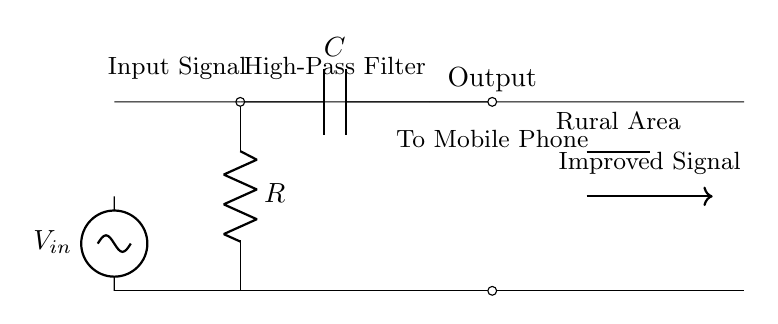What is the input voltage indicated in the diagram? The input voltage is labeled as V_in, which is represented as a voltage source on the diagram.
Answer: V_in What type of filter is represented in this circuit? The circuit diagram clearly states "High-Pass Filter" at the top, indicating the type of filter.
Answer: High-Pass Filter What component is connected to the output of this circuit? The output is connected to the mobile phone component, which is indicated by "To Mobile Phone" under the output connection.
Answer: Mobile Phone What is the role of the capacitor in this circuit? The capacitor is used in a high-pass filter configuration to allow high-frequency signals to pass while blocking lower frequencies, which is essential for improving mobile signals.
Answer: Allow high frequencies How many resistors are present in the circuit? Only one resistor is clearly labeled as R in the circuit diagram.
Answer: One Which area does the circuit diagram aim to improve signal reception in? The diagram includes a note stating "Rural Area," showing the targeted location for improving mobile signal reception.
Answer: Rural Area What is the function of the antenna shown in the circuit? The antenna is used to receive radio signals for mobile communication, and its placement in the circuit is crucial for effective signal reception.
Answer: Receive signals 